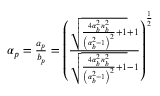Convert formula to latex. <formula><loc_0><loc_0><loc_500><loc_500>\begin{array} { r } { \alpha _ { p } = \frac { a _ { p } } { b _ { p } } = \left ( \frac { \sqrt { \frac { 4 \alpha _ { b } ^ { 2 } n _ { b } ^ { 2 } } { \left ( \alpha _ { b } ^ { 2 } - 1 \right ) ^ { 2 } } + 1 } + 1 } { \sqrt { \frac { 4 \alpha _ { b } ^ { 2 } n _ { b } ^ { 2 } } { \left ( \alpha _ { b } ^ { 2 } - 1 \right ) ^ { 2 } } + 1 } - 1 } \right ) ^ { \frac { 1 } { 2 } } } \end{array}</formula> 